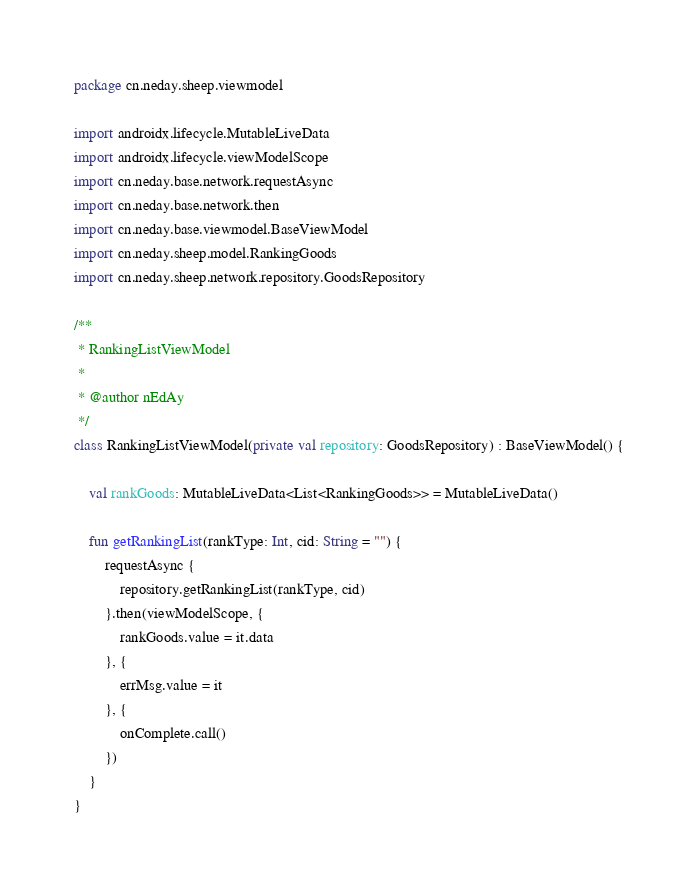<code> <loc_0><loc_0><loc_500><loc_500><_Kotlin_>package cn.neday.sheep.viewmodel

import androidx.lifecycle.MutableLiveData
import androidx.lifecycle.viewModelScope
import cn.neday.base.network.requestAsync
import cn.neday.base.network.then
import cn.neday.base.viewmodel.BaseViewModel
import cn.neday.sheep.model.RankingGoods
import cn.neday.sheep.network.repository.GoodsRepository

/**
 * RankingListViewModel
 *
 * @author nEdAy
 */
class RankingListViewModel(private val repository: GoodsRepository) : BaseViewModel() {

    val rankGoods: MutableLiveData<List<RankingGoods>> = MutableLiveData()

    fun getRankingList(rankType: Int, cid: String = "") {
        requestAsync {
            repository.getRankingList(rankType, cid)
        }.then(viewModelScope, {
            rankGoods.value = it.data
        }, {
            errMsg.value = it
        }, {
            onComplete.call()
        })
    }
}</code> 